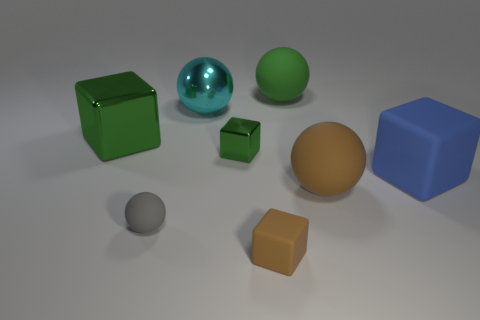Subtract all brown rubber cubes. How many cubes are left? 3 Subtract 1 brown cubes. How many objects are left? 7 Subtract 3 blocks. How many blocks are left? 1 Subtract all brown cubes. Subtract all gray balls. How many cubes are left? 3 Subtract all blue cylinders. How many green balls are left? 1 Subtract all big cyan balls. Subtract all big metal objects. How many objects are left? 5 Add 7 tiny brown rubber objects. How many tiny brown rubber objects are left? 8 Add 4 balls. How many balls exist? 8 Add 2 large brown rubber things. How many objects exist? 10 Subtract all brown cubes. How many cubes are left? 3 